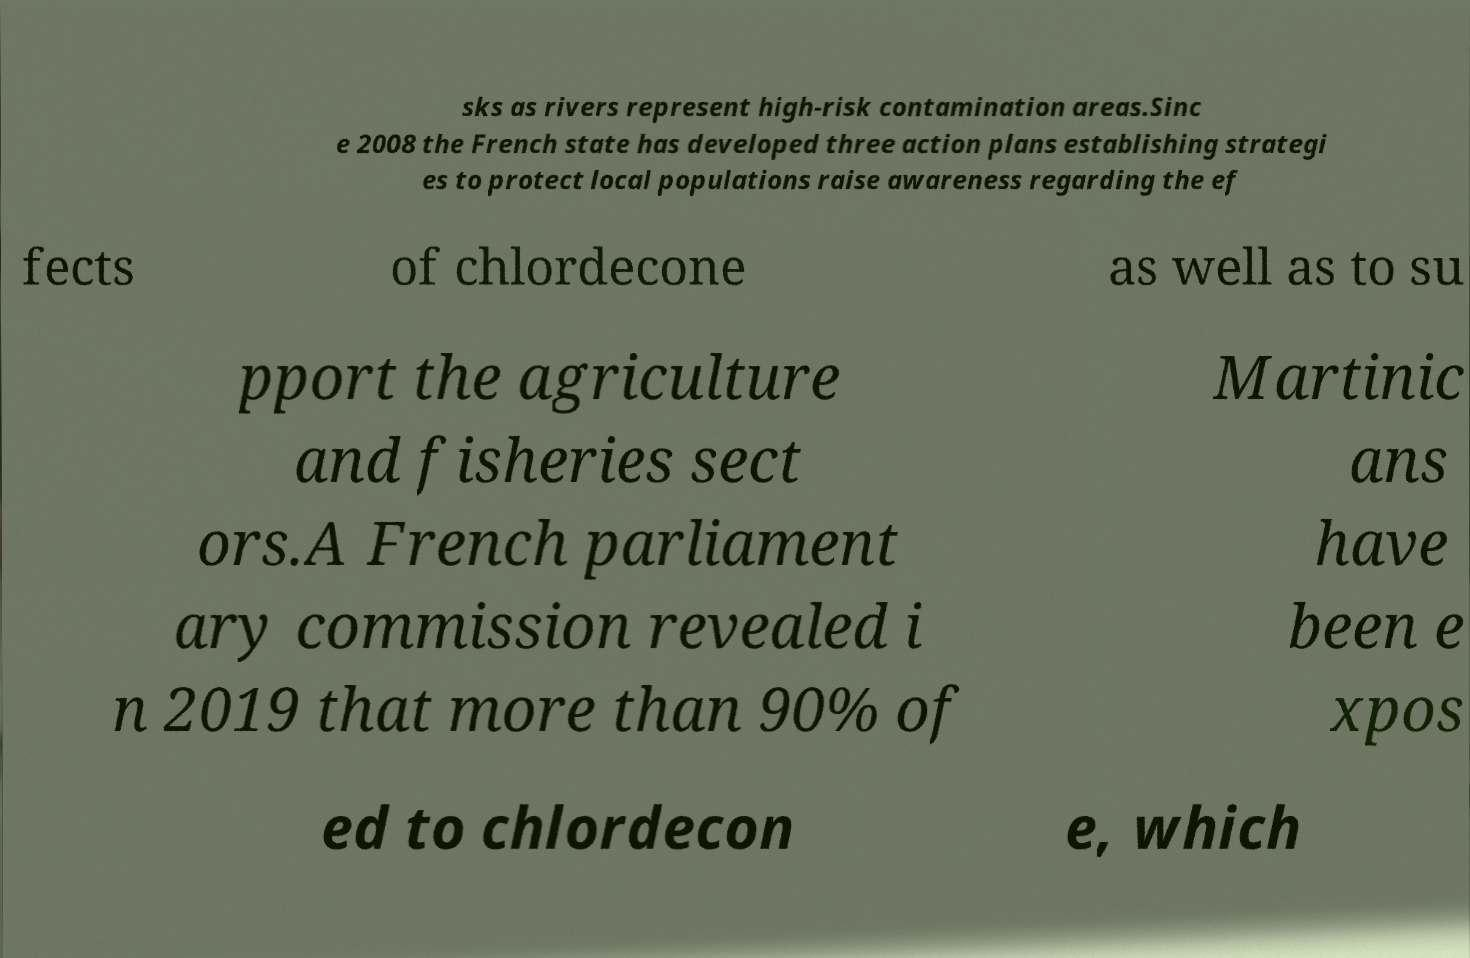Can you accurately transcribe the text from the provided image for me? sks as rivers represent high-risk contamination areas.Sinc e 2008 the French state has developed three action plans establishing strategi es to protect local populations raise awareness regarding the ef fects of chlordecone as well as to su pport the agriculture and fisheries sect ors.A French parliament ary commission revealed i n 2019 that more than 90% of Martinic ans have been e xpos ed to chlordecon e, which 